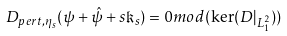Convert formula to latex. <formula><loc_0><loc_0><loc_500><loc_500>D _ { p e r t , \eta _ { s } } ( \psi + \hat { \psi } + s \mathfrak { k } _ { s } ) = 0 m o d ( \ker ( D | _ { L ^ { 2 } _ { 1 } } ) )</formula> 